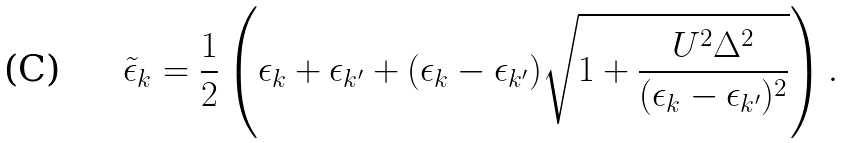Convert formula to latex. <formula><loc_0><loc_0><loc_500><loc_500>\tilde { \epsilon } _ { k } = \frac { 1 } { 2 } \left ( \epsilon _ { k } + \epsilon _ { { k } ^ { \prime } } + ( \epsilon _ { k } - \epsilon _ { { k } ^ { \prime } } ) \sqrt { 1 + \frac { U ^ { 2 } \Delta ^ { 2 } } { ( \epsilon _ { k } - \epsilon _ { { k } ^ { \prime } } ) ^ { 2 } } } \right ) .</formula> 